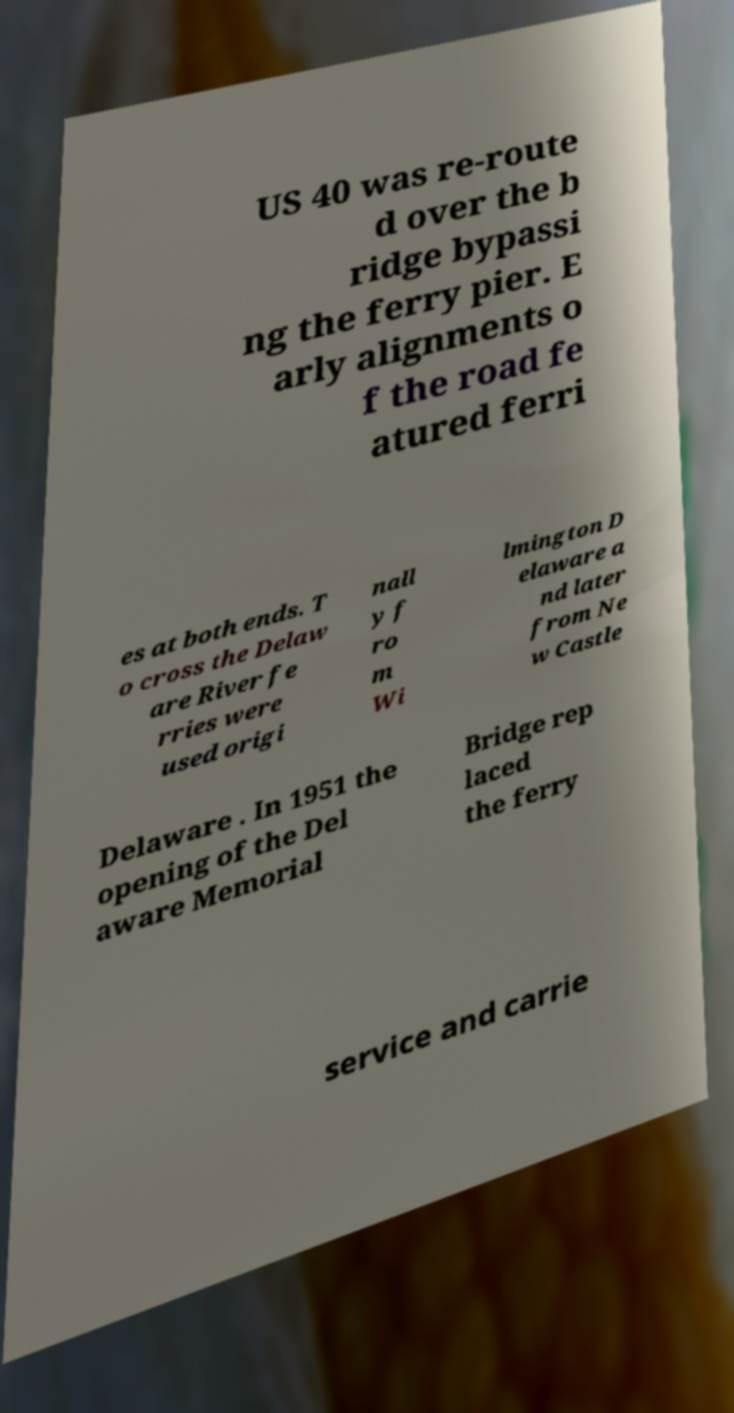There's text embedded in this image that I need extracted. Can you transcribe it verbatim? US 40 was re-route d over the b ridge bypassi ng the ferry pier. E arly alignments o f the road fe atured ferri es at both ends. T o cross the Delaw are River fe rries were used origi nall y f ro m Wi lmington D elaware a nd later from Ne w Castle Delaware . In 1951 the opening of the Del aware Memorial Bridge rep laced the ferry service and carrie 